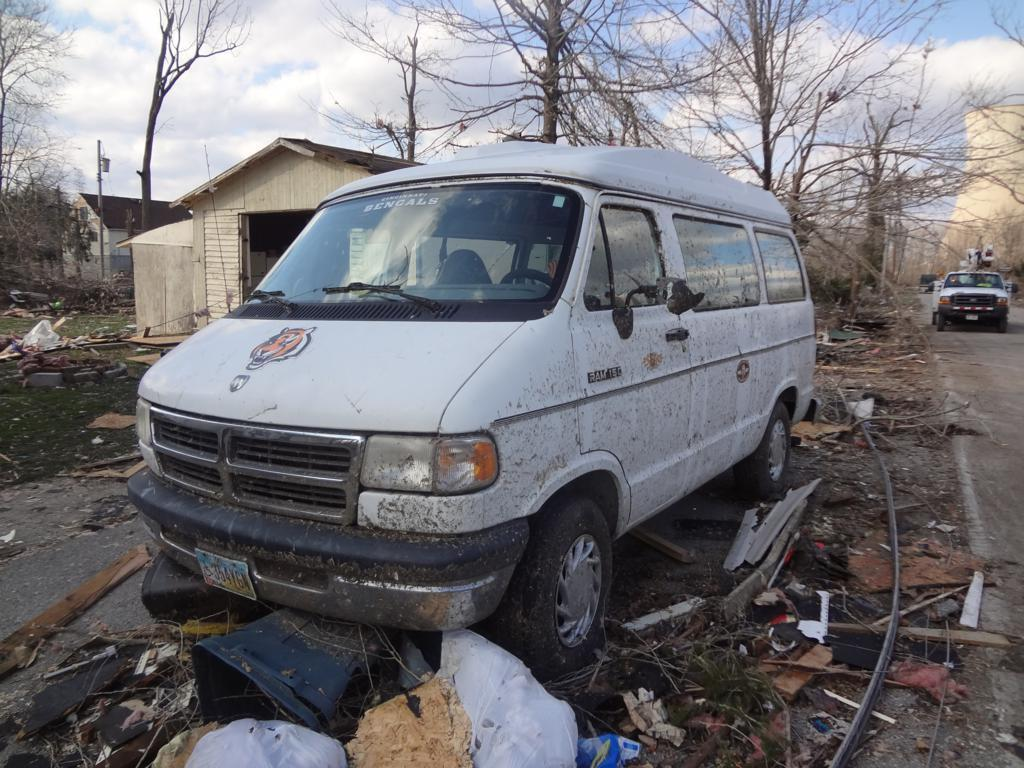<image>
Share a concise interpretation of the image provided. A dirty Ram 150 van with a Bengals sign in the windshield. 